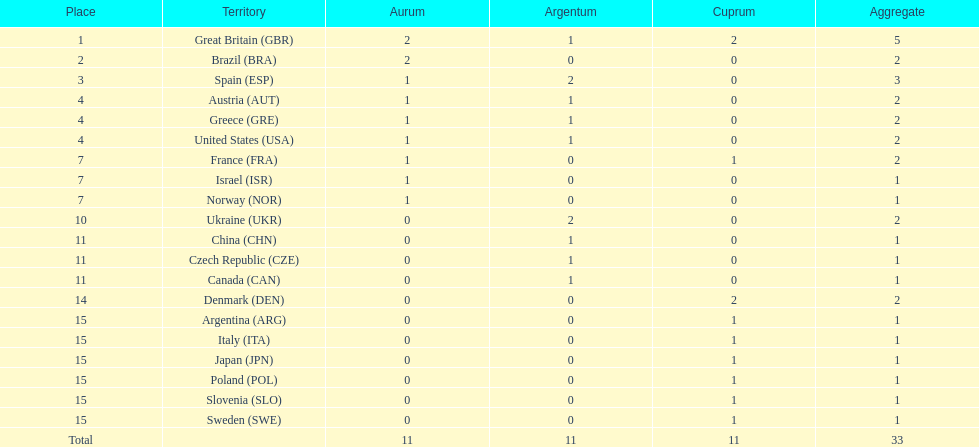What was the total number of medals won by united states? 2. 